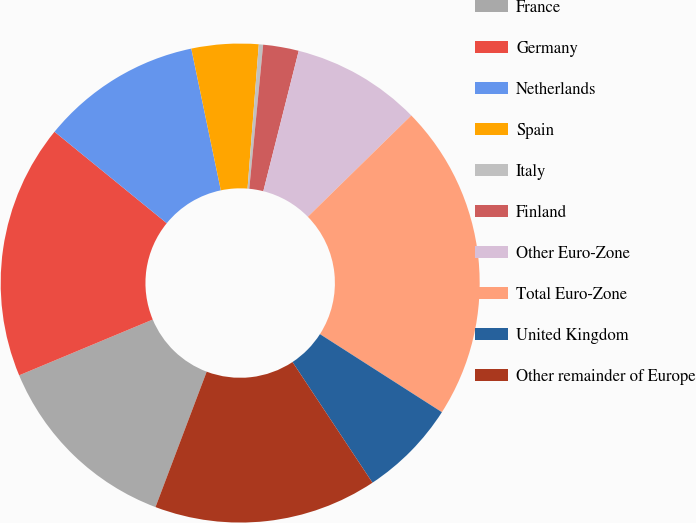Convert chart to OTSL. <chart><loc_0><loc_0><loc_500><loc_500><pie_chart><fcel>France<fcel>Germany<fcel>Netherlands<fcel>Spain<fcel>Italy<fcel>Finland<fcel>Other Euro-Zone<fcel>Total Euro-Zone<fcel>United Kingdom<fcel>Other remainder of Europe<nl><fcel>12.95%<fcel>17.17%<fcel>10.84%<fcel>4.51%<fcel>0.29%<fcel>2.4%<fcel>8.73%<fcel>21.39%<fcel>6.62%<fcel>15.06%<nl></chart> 